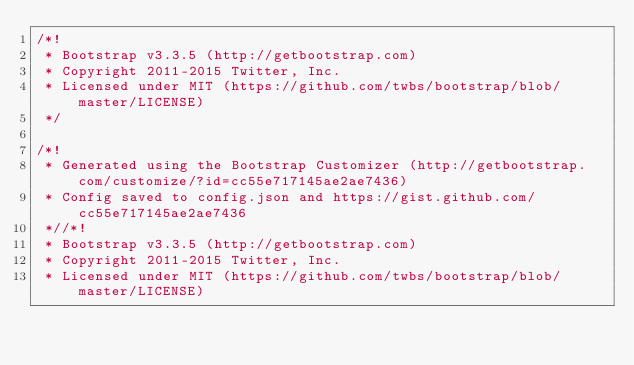<code> <loc_0><loc_0><loc_500><loc_500><_CSS_>/*!
 * Bootstrap v3.3.5 (http://getbootstrap.com)
 * Copyright 2011-2015 Twitter, Inc.
 * Licensed under MIT (https://github.com/twbs/bootstrap/blob/master/LICENSE)
 */

/*!
 * Generated using the Bootstrap Customizer (http://getbootstrap.com/customize/?id=cc55e717145ae2ae7436)
 * Config saved to config.json and https://gist.github.com/cc55e717145ae2ae7436
 *//*!
 * Bootstrap v3.3.5 (http://getbootstrap.com)
 * Copyright 2011-2015 Twitter, Inc.
 * Licensed under MIT (https://github.com/twbs/bootstrap/blob/master/LICENSE)</code> 